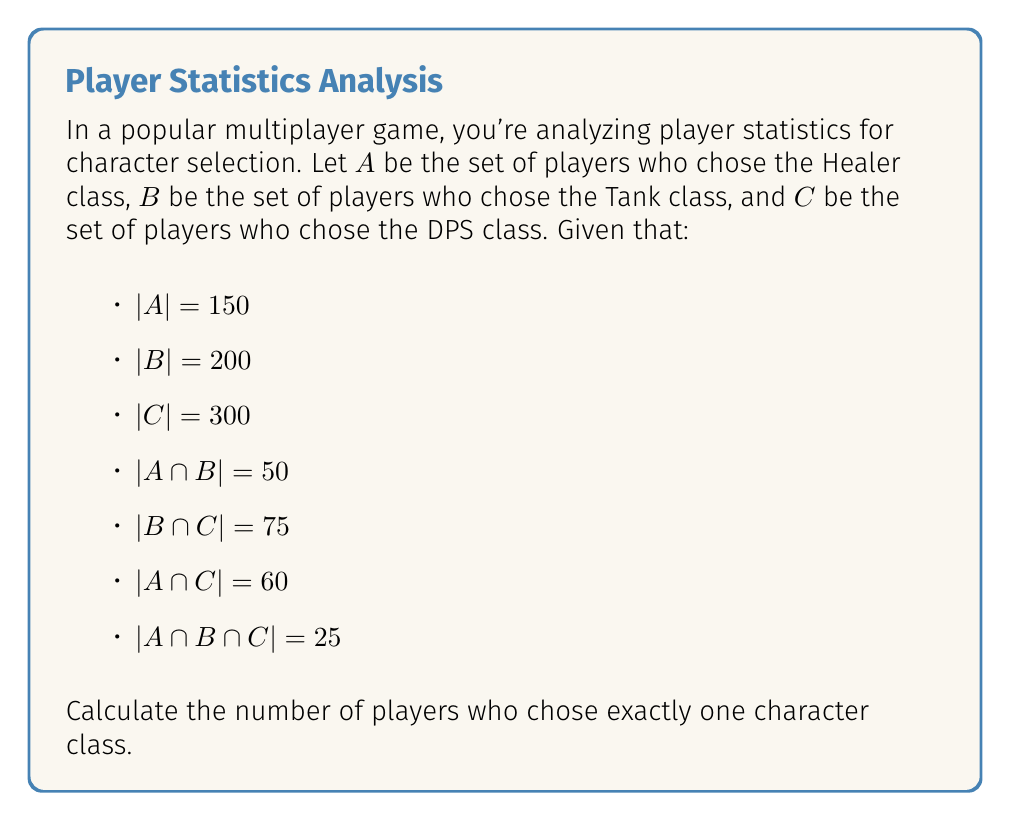What is the answer to this math problem? To solve this problem, we'll use the Inclusion-Exclusion Principle and set theory concepts.

1. First, let's calculate the total number of players who chose at least one class:
   $|A \cup B \cup C| = |A| + |B| + |C| - |A \cap B| - |B \cap C| - |A \cap C| + |A \cap B \cap C|$

2. Substituting the given values:
   $|A \cup B \cup C| = 150 + 200 + 300 - 50 - 75 - 60 + 25 = 490$

3. Now, we need to find the number of players who chose exactly one class. This can be calculated by subtracting the number of players who chose two or more classes from the total number of players who chose at least one class.

4. Players who chose two or more classes:
   $|(\text{2 or more classes})| = |A \cap B| + |B \cap C| + |A \cap C| - 2|A \cap B \cap C|$
   $= 50 + 75 + 60 - 2(25) = 135$

5. Players who chose exactly one class:
   $|(\text{exactly one class})| = |A \cup B \cup C| - |(\text{2 or more classes})|$
   $= 490 - 135 = 355$

Therefore, 355 players chose exactly one character class.
Answer: 355 players 